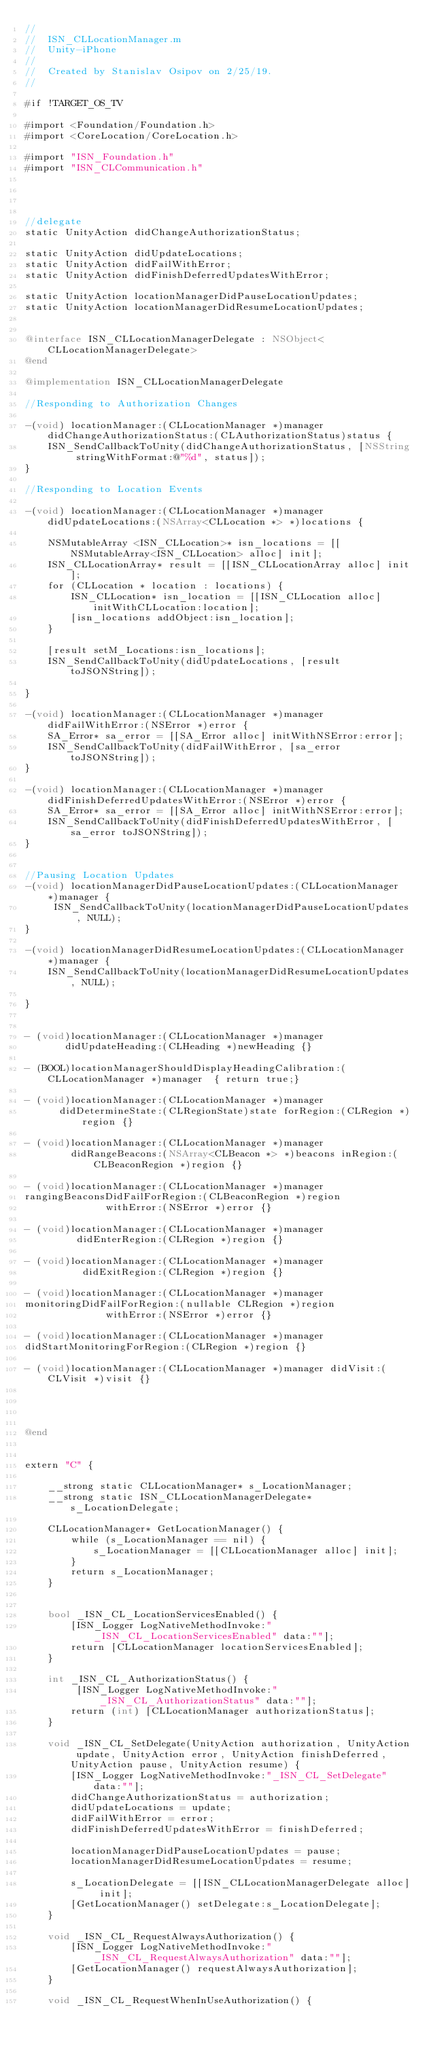Convert code to text. <code><loc_0><loc_0><loc_500><loc_500><_ObjectiveC_>//
//  ISN_CLLocationManager.m
//  Unity-iPhone
//
//  Created by Stanislav Osipov on 2/25/19.
//

#if !TARGET_OS_TV

#import <Foundation/Foundation.h>
#import <CoreLocation/CoreLocation.h>

#import "ISN_Foundation.h"
#import "ISN_CLCommunication.h"




//delegate
static UnityAction didChangeAuthorizationStatus;

static UnityAction didUpdateLocations;
static UnityAction didFailWithError;
static UnityAction didFinishDeferredUpdatesWithError;

static UnityAction locationManagerDidPauseLocationUpdates;
static UnityAction locationManagerDidResumeLocationUpdates;


@interface ISN_CLLocationManagerDelegate : NSObject<CLLocationManagerDelegate>
@end

@implementation ISN_CLLocationManagerDelegate

//Responding to Authorization Changes

-(void) locationManager:(CLLocationManager *)manager didChangeAuthorizationStatus:(CLAuthorizationStatus)status {
    ISN_SendCallbackToUnity(didChangeAuthorizationStatus, [NSString stringWithFormat:@"%d", status]);
}

//Responding to Location Events

-(void) locationManager:(CLLocationManager *)manager didUpdateLocations:(NSArray<CLLocation *> *)locations {
    
    NSMutableArray <ISN_CLLocation>* isn_locations = [[NSMutableArray<ISN_CLLocation> alloc] init];
    ISN_CLLocationArray* result = [[ISN_CLLocationArray alloc] init];
    for (CLLocation * location : locations) {
        ISN_CLLocation* isn_location = [[ISN_CLLocation alloc] initWithCLLocation:location];
        [isn_locations addObject:isn_location];
    }
    
    [result setM_Locations:isn_locations];
    ISN_SendCallbackToUnity(didUpdateLocations, [result toJSONString]);
    
}

-(void) locationManager:(CLLocationManager *)manager didFailWithError:(NSError *)error {
    SA_Error* sa_error = [[SA_Error alloc] initWithNSError:error];
    ISN_SendCallbackToUnity(didFailWithError, [sa_error toJSONString]);
}

-(void) locationManager:(CLLocationManager *)manager didFinishDeferredUpdatesWithError:(NSError *)error {
    SA_Error* sa_error = [[SA_Error alloc] initWithNSError:error];
    ISN_SendCallbackToUnity(didFinishDeferredUpdatesWithError, [sa_error toJSONString]);
}


//Pausing Location Updates
-(void) locationManagerDidPauseLocationUpdates:(CLLocationManager *)manager {
     ISN_SendCallbackToUnity(locationManagerDidPauseLocationUpdates, NULL);
}

-(void) locationManagerDidResumeLocationUpdates:(CLLocationManager *)manager {
    ISN_SendCallbackToUnity(locationManagerDidResumeLocationUpdates, NULL);
    
}


- (void)locationManager:(CLLocationManager *)manager
       didUpdateHeading:(CLHeading *)newHeading {}

- (BOOL)locationManagerShouldDisplayHeadingCalibration:(CLLocationManager *)manager  { return true;}

- (void)locationManager:(CLLocationManager *)manager
      didDetermineState:(CLRegionState)state forRegion:(CLRegion *)region {}

- (void)locationManager:(CLLocationManager *)manager
        didRangeBeacons:(NSArray<CLBeacon *> *)beacons inRegion:(CLBeaconRegion *)region {}

- (void)locationManager:(CLLocationManager *)manager
rangingBeaconsDidFailForRegion:(CLBeaconRegion *)region
              withError:(NSError *)error {}

- (void)locationManager:(CLLocationManager *)manager
         didEnterRegion:(CLRegion *)region {}

- (void)locationManager:(CLLocationManager *)manager
          didExitRegion:(CLRegion *)region {}

- (void)locationManager:(CLLocationManager *)manager
monitoringDidFailForRegion:(nullable CLRegion *)region
              withError:(NSError *)error {}

- (void)locationManager:(CLLocationManager *)manager
didStartMonitoringForRegion:(CLRegion *)region {}

- (void)locationManager:(CLLocationManager *)manager didVisit:(CLVisit *)visit {}




@end


extern "C" {
    
    __strong static CLLocationManager* s_LocationManager;
    __strong static ISN_CLLocationManagerDelegate* s_LocationDelegate;
    
    CLLocationManager* GetLocationManager() {
        while (s_LocationManager == nil) {
            s_LocationManager = [[CLLocationManager alloc] init];
        }
        return s_LocationManager;
    }
    
    
    bool _ISN_CL_LocationServicesEnabled() {
        [ISN_Logger LogNativeMethodInvoke:"_ISN_CL_LocationServicesEnabled" data:""];
        return [CLLocationManager locationServicesEnabled];
    }
    
    int _ISN_CL_AuthorizationStatus() {
         [ISN_Logger LogNativeMethodInvoke:"_ISN_CL_AuthorizationStatus" data:""];
        return (int) [CLLocationManager authorizationStatus];
    }
    
    void _ISN_CL_SetDelegate(UnityAction authorization, UnityAction update, UnityAction error, UnityAction finishDeferred, UnityAction pause, UnityAction resume) {
        [ISN_Logger LogNativeMethodInvoke:"_ISN_CL_SetDelegate" data:""];
        didChangeAuthorizationStatus = authorization;
        didUpdateLocations = update;
        didFailWithError = error;
        didFinishDeferredUpdatesWithError = finishDeferred;
        
        locationManagerDidPauseLocationUpdates = pause;
        locationManagerDidResumeLocationUpdates = resume;
        
        s_LocationDelegate = [[ISN_CLLocationManagerDelegate alloc] init];
        [GetLocationManager() setDelegate:s_LocationDelegate];
    }
   
    void _ISN_CL_RequestAlwaysAuthorization() {
        [ISN_Logger LogNativeMethodInvoke:"_ISN_CL_RequestAlwaysAuthorization" data:""];
        [GetLocationManager() requestAlwaysAuthorization];
    }
    
    void _ISN_CL_RequestWhenInUseAuthorization() {</code> 